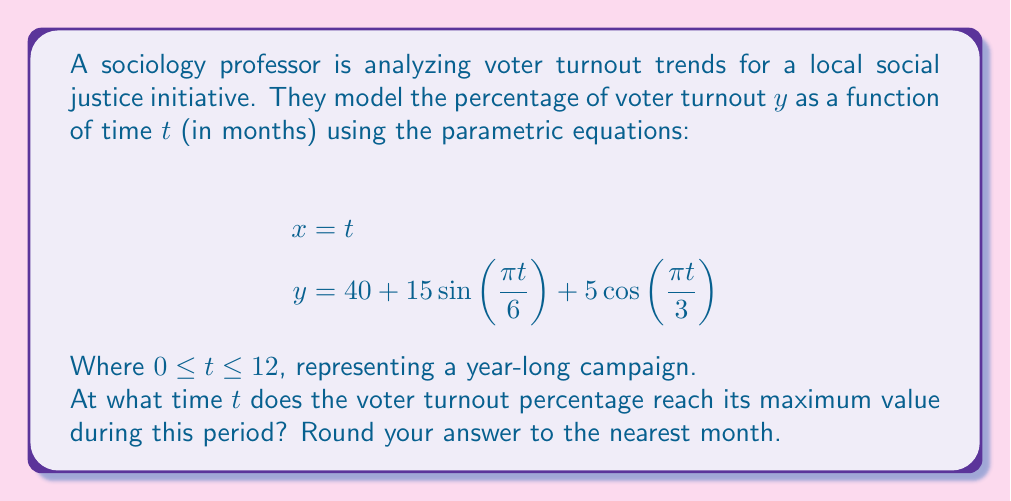Show me your answer to this math problem. To find the maximum value of $y$, we need to find the critical points of the function. Since $y$ is given as a function of the parameter $t$, we can differentiate $y$ with respect to $t$ and set it equal to zero:

$$\frac{dy}{dt} = 15 \cdot \frac{\pi}{6} \cos(\frac{\pi t}{6}) - 5 \cdot \frac{\pi}{3} \sin(\frac{\pi t}{3})$$

Setting this equal to zero:

$$15 \cdot \frac{\pi}{6} \cos(\frac{\pi t}{6}) - 5 \cdot \frac{\pi}{3} \sin(\frac{\pi t}{3}) = 0$$

Simplifying:

$$5\pi \cos(\frac{\pi t}{6}) - 5\pi \sin(\frac{\pi t}{3}) = 0$$

$$\cos(\frac{\pi t}{6}) = \sin(\frac{\pi t}{3})$$

This equation is satisfied when $\frac{\pi t}{6} = \frac{\pi}{6}$ or $t = 1$, and when $\frac{\pi t}{6} = \frac{5\pi}{6}$ or $t = 5$.

To determine which of these critical points gives the maximum, we can evaluate $y$ at $t = 1$ and $t = 5$:

At $t = 1$: $y = 40 + 15\sin(\frac{\pi}{6}) + 5\cos(\frac{\pi}{3}) \approx 54.33$

At $t = 5$: $y = 40 + 15\sin(\frac{5\pi}{6}) - 5\cos(\frac{5\pi}{3}) \approx 54.33$

Since these values are equal and there are no other critical points in the interval $[0, 12]$, we can conclude that the maximum occurs at both $t = 1$ and $t = 5$.

The question asks for the answer rounded to the nearest month, so either 1 or 5 would be correct. However, since 1 occurs earlier in the campaign, it's more relevant for predicting and planning purposes.
Answer: 1 month 